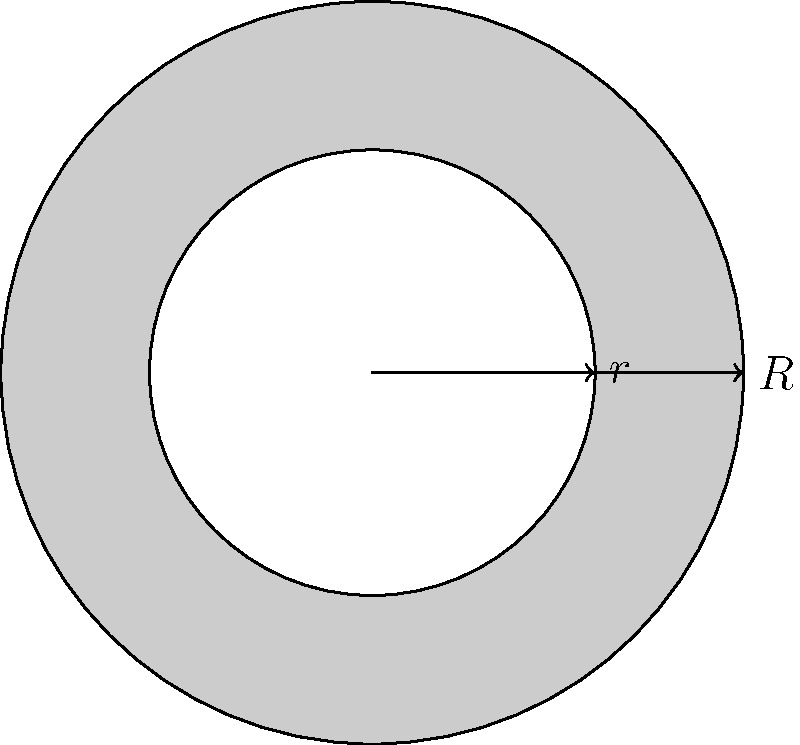You're tuning up your Turismo Carretera race car and need to calculate the moment of inertia for one of its wheels. The wheel has a uniform density and can be approximated as a solid disk with an inner circular cutout. The outer radius (R) is 30 cm, and the inner radius (r) is 18 cm. If the wheel's mass is 15 kg, what is its moment of inertia about the central axis? Let's approach this step-by-step:

1) The moment of inertia for a solid disk about its central axis is given by:
   $$I_{solid} = \frac{1}{2}MR^2$$

2) For a disk with a circular cutout, we can use the principle of superposition. We subtract the moment of inertia of the inner "missing" disk from the moment of inertia of the full disk:
   $$I = I_{outer} - I_{inner}$$

3) We need to find the mass of the inner disk. The ratio of the masses will be proportional to the ratio of the areas:
   $$\frac{M_{inner}}{M_{total}} = \frac{A_{inner}}{A_{total}} = \frac{\pi r^2}{\pi R^2} = \frac{r^2}{R^2}$$

4) Solving for $M_{inner}$:
   $$M_{inner} = M_{total} \cdot \frac{r^2}{R^2} = 15 \cdot \frac{18^2}{30^2} = 5.4 \text{ kg}$$

5) Now we can calculate the moment of inertia:
   $$I = \frac{1}{2}M_{total}R^2 - \frac{1}{2}M_{inner}r^2$$

6) Plugging in the values:
   $$I = \frac{1}{2} \cdot 15 \cdot 0.3^2 - \frac{1}{2} \cdot 5.4 \cdot 0.18^2$$

7) Calculating:
   $$I = 0.675 - 0.08748 = 0.58752 \text{ kg}\cdot\text{m}^2$$
Answer: 0.58752 kg·m² 